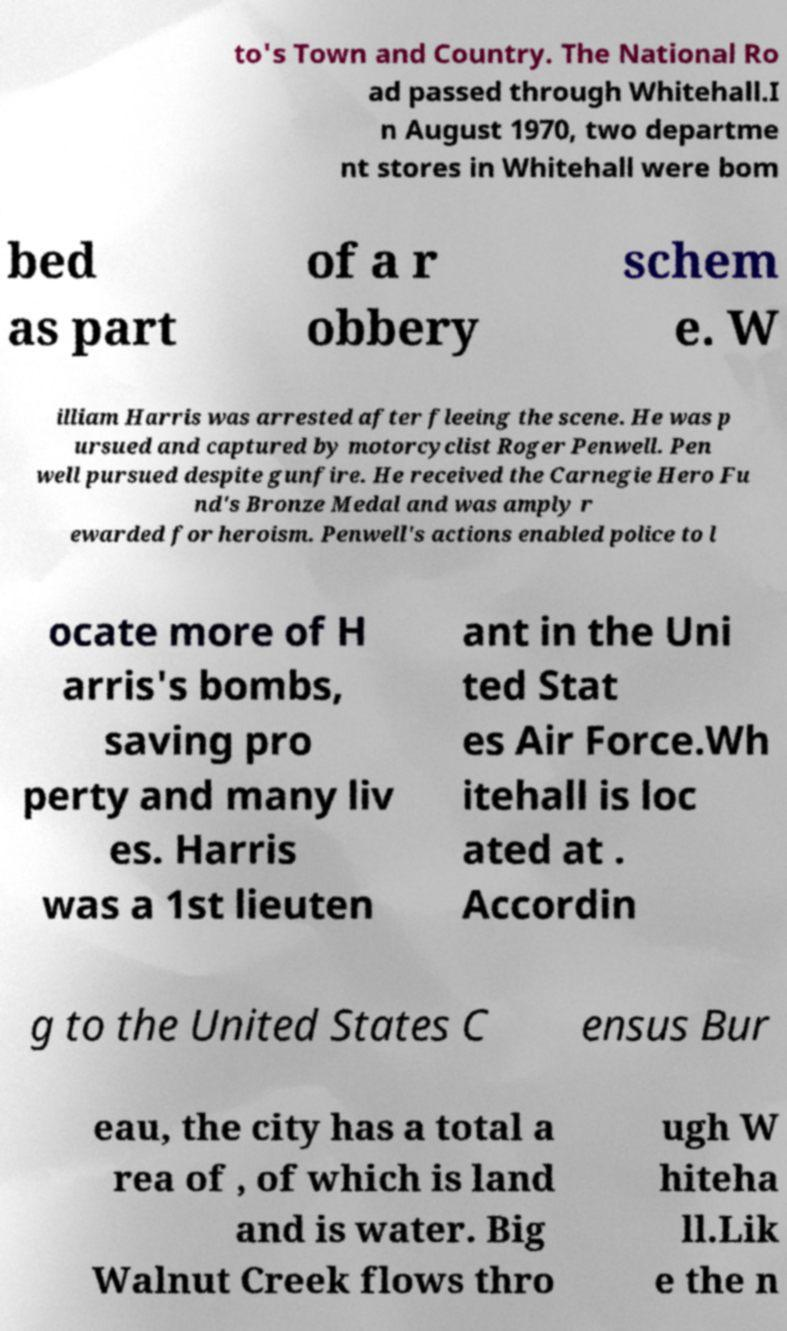For documentation purposes, I need the text within this image transcribed. Could you provide that? to's Town and Country. The National Ro ad passed through Whitehall.I n August 1970, two departme nt stores in Whitehall were bom bed as part of a r obbery schem e. W illiam Harris was arrested after fleeing the scene. He was p ursued and captured by motorcyclist Roger Penwell. Pen well pursued despite gunfire. He received the Carnegie Hero Fu nd's Bronze Medal and was amply r ewarded for heroism. Penwell's actions enabled police to l ocate more of H arris's bombs, saving pro perty and many liv es. Harris was a 1st lieuten ant in the Uni ted Stat es Air Force.Wh itehall is loc ated at . Accordin g to the United States C ensus Bur eau, the city has a total a rea of , of which is land and is water. Big Walnut Creek flows thro ugh W hiteha ll.Lik e the n 